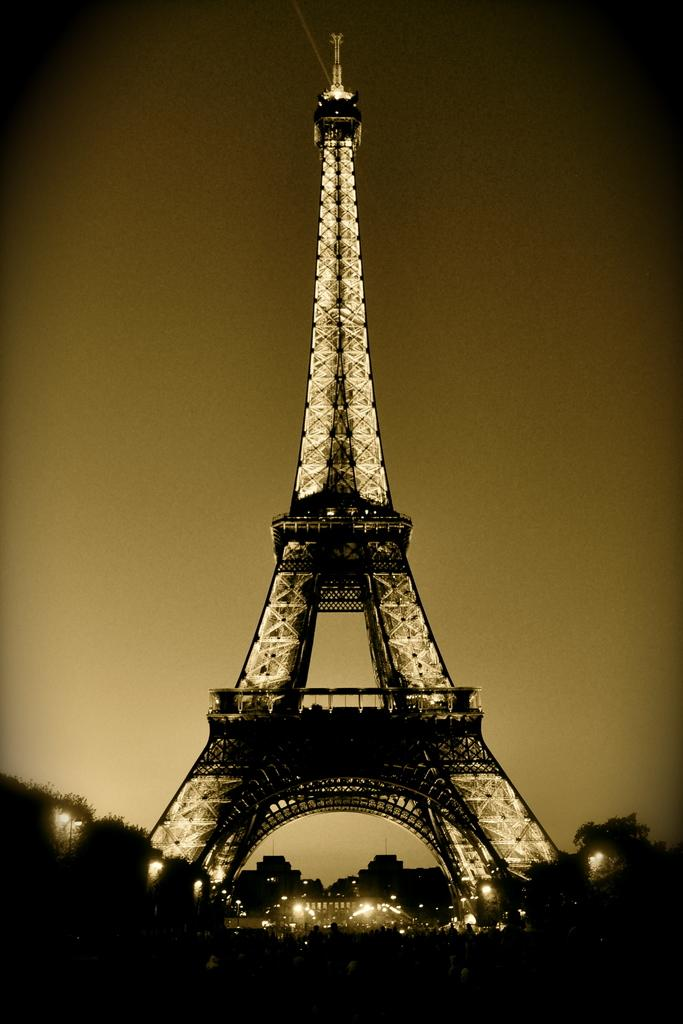What famous landmark is shown in the image? The image depicts the Eiffel tower. What time of day is it in the image? The Eiffel tower is in the nighttime in the image. Are there any special features of the Eiffel tower in the image? Yes, the Eiffel tower has lights in the image. What is the color scheme of the image? The image is black and white. What type of thought can be seen floating above the Eiffel tower in the image? There are no thoughts visible in the image, as thoughts are not a physical object that can be seen. 